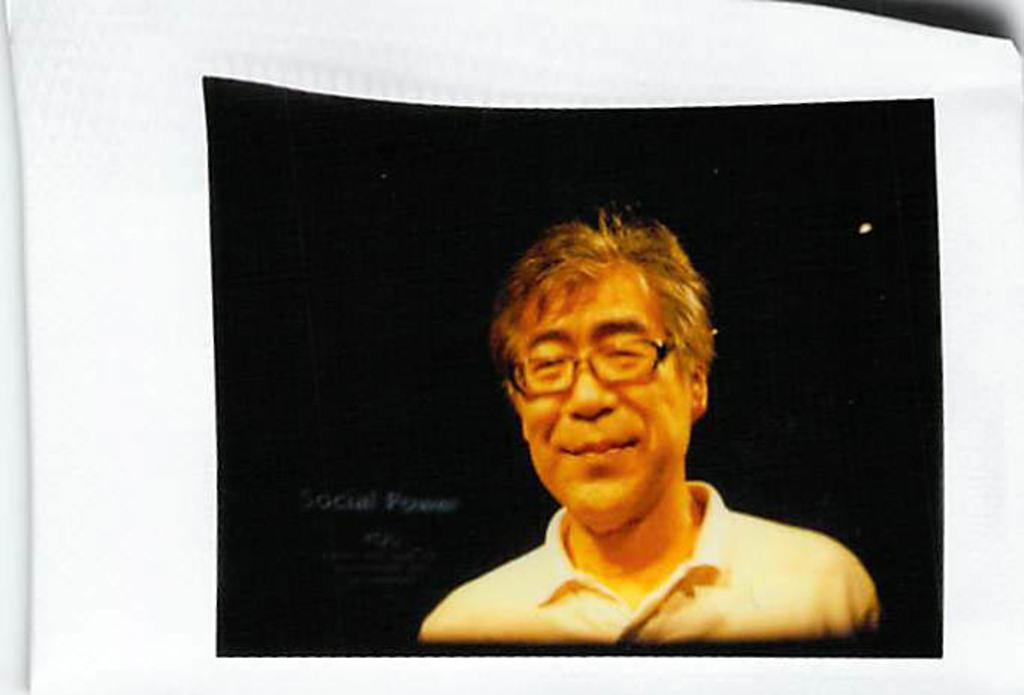What is featured on the poster in the image? There is a poster in the image, and it has a picture of a person. What is the person in the poster wearing? The person in the poster is wearing a shirt and spectacles. How many tomatoes are being kicked by the person in the poster? There are no tomatoes or kicking action present in the image; the poster features a person wearing a shirt and spectacles. 